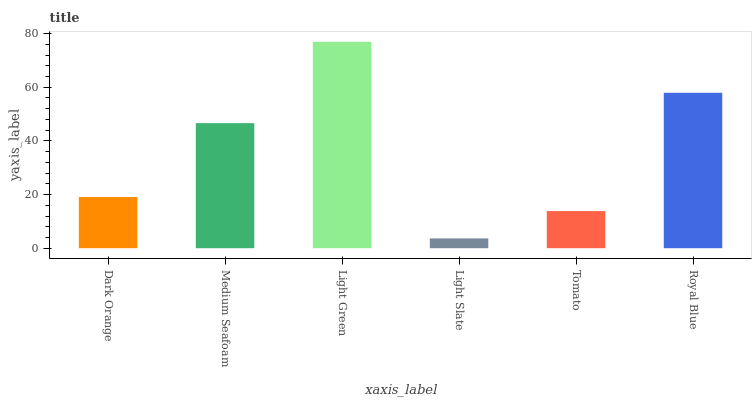Is Light Slate the minimum?
Answer yes or no. Yes. Is Light Green the maximum?
Answer yes or no. Yes. Is Medium Seafoam the minimum?
Answer yes or no. No. Is Medium Seafoam the maximum?
Answer yes or no. No. Is Medium Seafoam greater than Dark Orange?
Answer yes or no. Yes. Is Dark Orange less than Medium Seafoam?
Answer yes or no. Yes. Is Dark Orange greater than Medium Seafoam?
Answer yes or no. No. Is Medium Seafoam less than Dark Orange?
Answer yes or no. No. Is Medium Seafoam the high median?
Answer yes or no. Yes. Is Dark Orange the low median?
Answer yes or no. Yes. Is Light Slate the high median?
Answer yes or no. No. Is Light Green the low median?
Answer yes or no. No. 